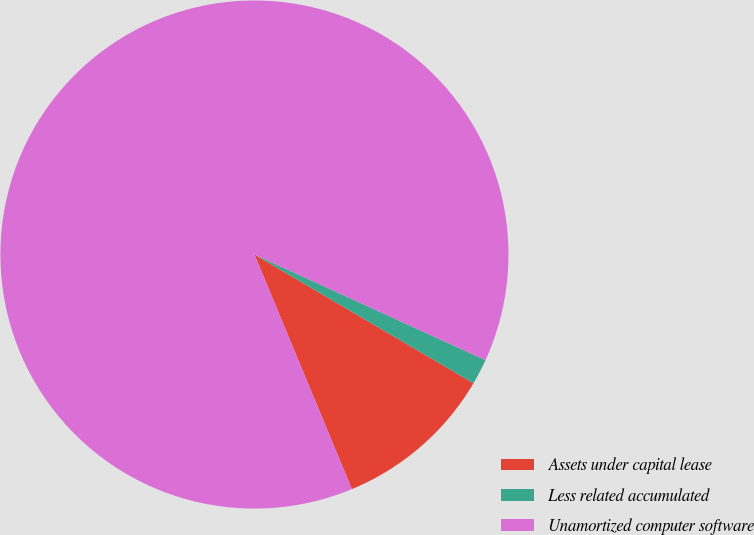Convert chart to OTSL. <chart><loc_0><loc_0><loc_500><loc_500><pie_chart><fcel>Assets under capital lease<fcel>Less related accumulated<fcel>Unamortized computer software<nl><fcel>10.28%<fcel>1.63%<fcel>88.09%<nl></chart> 